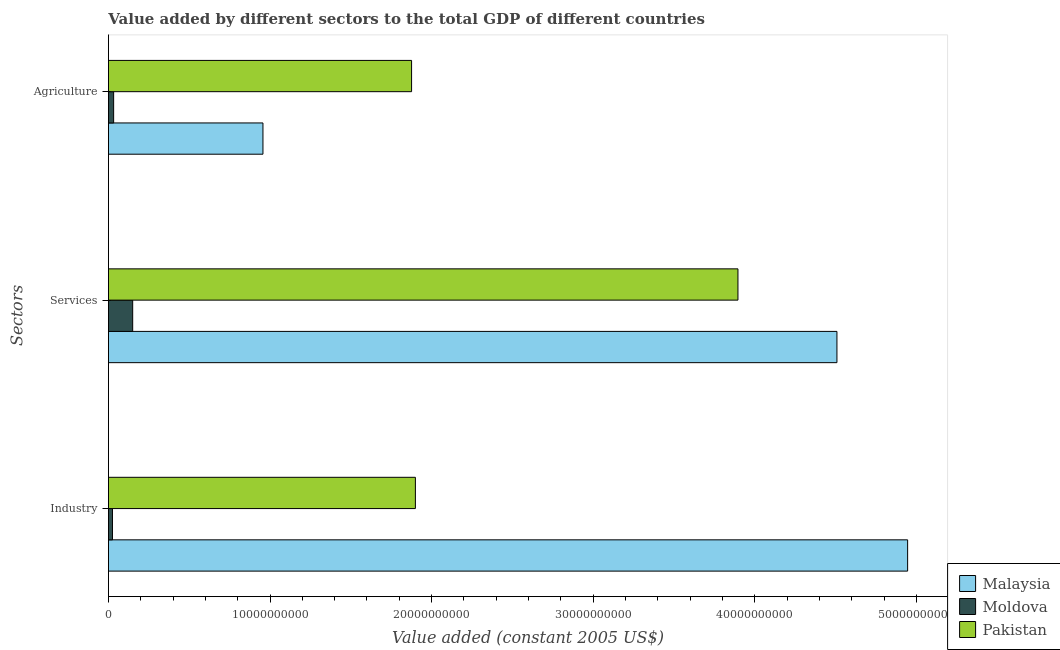How many groups of bars are there?
Give a very brief answer. 3. Are the number of bars per tick equal to the number of legend labels?
Ensure brevity in your answer.  Yes. How many bars are there on the 3rd tick from the top?
Make the answer very short. 3. How many bars are there on the 1st tick from the bottom?
Provide a succinct answer. 3. What is the label of the 1st group of bars from the top?
Your answer should be very brief. Agriculture. What is the value added by agricultural sector in Moldova?
Provide a short and direct response. 3.22e+08. Across all countries, what is the maximum value added by services?
Offer a very short reply. 4.51e+1. Across all countries, what is the minimum value added by agricultural sector?
Your answer should be very brief. 3.22e+08. In which country was the value added by industrial sector maximum?
Your answer should be compact. Malaysia. In which country was the value added by industrial sector minimum?
Provide a short and direct response. Moldova. What is the total value added by industrial sector in the graph?
Make the answer very short. 6.87e+1. What is the difference between the value added by agricultural sector in Pakistan and that in Moldova?
Offer a very short reply. 1.84e+1. What is the difference between the value added by agricultural sector in Pakistan and the value added by services in Malaysia?
Keep it short and to the point. -2.63e+1. What is the average value added by agricultural sector per country?
Ensure brevity in your answer.  9.55e+09. What is the difference between the value added by industrial sector and value added by services in Moldova?
Offer a very short reply. -1.25e+09. In how many countries, is the value added by services greater than 46000000000 US$?
Offer a terse response. 0. What is the ratio of the value added by services in Malaysia to that in Moldova?
Your response must be concise. 30.03. Is the value added by agricultural sector in Moldova less than that in Pakistan?
Provide a short and direct response. Yes. Is the difference between the value added by industrial sector in Malaysia and Pakistan greater than the difference between the value added by services in Malaysia and Pakistan?
Provide a short and direct response. Yes. What is the difference between the highest and the second highest value added by industrial sector?
Your response must be concise. 3.05e+1. What is the difference between the highest and the lowest value added by services?
Provide a short and direct response. 4.36e+1. In how many countries, is the value added by industrial sector greater than the average value added by industrial sector taken over all countries?
Keep it short and to the point. 1. What does the 3rd bar from the top in Services represents?
Your answer should be compact. Malaysia. What does the 1st bar from the bottom in Industry represents?
Keep it short and to the point. Malaysia. Is it the case that in every country, the sum of the value added by industrial sector and value added by services is greater than the value added by agricultural sector?
Provide a short and direct response. Yes. Are all the bars in the graph horizontal?
Offer a terse response. Yes. How many countries are there in the graph?
Provide a short and direct response. 3. Does the graph contain any zero values?
Provide a succinct answer. No. Where does the legend appear in the graph?
Your answer should be very brief. Bottom right. How many legend labels are there?
Your response must be concise. 3. How are the legend labels stacked?
Your response must be concise. Vertical. What is the title of the graph?
Offer a terse response. Value added by different sectors to the total GDP of different countries. Does "Japan" appear as one of the legend labels in the graph?
Give a very brief answer. No. What is the label or title of the X-axis?
Give a very brief answer. Value added (constant 2005 US$). What is the label or title of the Y-axis?
Make the answer very short. Sectors. What is the Value added (constant 2005 US$) of Malaysia in Industry?
Your response must be concise. 4.95e+1. What is the Value added (constant 2005 US$) in Moldova in Industry?
Provide a short and direct response. 2.50e+08. What is the Value added (constant 2005 US$) of Pakistan in Industry?
Offer a very short reply. 1.90e+1. What is the Value added (constant 2005 US$) in Malaysia in Services?
Provide a succinct answer. 4.51e+1. What is the Value added (constant 2005 US$) in Moldova in Services?
Offer a terse response. 1.50e+09. What is the Value added (constant 2005 US$) of Pakistan in Services?
Ensure brevity in your answer.  3.90e+1. What is the Value added (constant 2005 US$) in Malaysia in Agriculture?
Provide a succinct answer. 9.56e+09. What is the Value added (constant 2005 US$) in Moldova in Agriculture?
Give a very brief answer. 3.22e+08. What is the Value added (constant 2005 US$) in Pakistan in Agriculture?
Keep it short and to the point. 1.88e+1. Across all Sectors, what is the maximum Value added (constant 2005 US$) in Malaysia?
Offer a very short reply. 4.95e+1. Across all Sectors, what is the maximum Value added (constant 2005 US$) of Moldova?
Your answer should be compact. 1.50e+09. Across all Sectors, what is the maximum Value added (constant 2005 US$) in Pakistan?
Ensure brevity in your answer.  3.90e+1. Across all Sectors, what is the minimum Value added (constant 2005 US$) in Malaysia?
Ensure brevity in your answer.  9.56e+09. Across all Sectors, what is the minimum Value added (constant 2005 US$) of Moldova?
Keep it short and to the point. 2.50e+08. Across all Sectors, what is the minimum Value added (constant 2005 US$) of Pakistan?
Your answer should be very brief. 1.88e+1. What is the total Value added (constant 2005 US$) of Malaysia in the graph?
Provide a short and direct response. 1.04e+11. What is the total Value added (constant 2005 US$) in Moldova in the graph?
Keep it short and to the point. 2.07e+09. What is the total Value added (constant 2005 US$) in Pakistan in the graph?
Give a very brief answer. 7.67e+1. What is the difference between the Value added (constant 2005 US$) of Malaysia in Industry and that in Services?
Your response must be concise. 4.37e+09. What is the difference between the Value added (constant 2005 US$) in Moldova in Industry and that in Services?
Provide a succinct answer. -1.25e+09. What is the difference between the Value added (constant 2005 US$) in Pakistan in Industry and that in Services?
Provide a short and direct response. -2.00e+1. What is the difference between the Value added (constant 2005 US$) of Malaysia in Industry and that in Agriculture?
Ensure brevity in your answer.  3.99e+1. What is the difference between the Value added (constant 2005 US$) of Moldova in Industry and that in Agriculture?
Provide a short and direct response. -7.22e+07. What is the difference between the Value added (constant 2005 US$) in Pakistan in Industry and that in Agriculture?
Provide a succinct answer. 2.36e+08. What is the difference between the Value added (constant 2005 US$) in Malaysia in Services and that in Agriculture?
Ensure brevity in your answer.  3.55e+1. What is the difference between the Value added (constant 2005 US$) in Moldova in Services and that in Agriculture?
Your answer should be very brief. 1.18e+09. What is the difference between the Value added (constant 2005 US$) in Pakistan in Services and that in Agriculture?
Keep it short and to the point. 2.02e+1. What is the difference between the Value added (constant 2005 US$) in Malaysia in Industry and the Value added (constant 2005 US$) in Moldova in Services?
Offer a very short reply. 4.80e+1. What is the difference between the Value added (constant 2005 US$) in Malaysia in Industry and the Value added (constant 2005 US$) in Pakistan in Services?
Offer a very short reply. 1.05e+1. What is the difference between the Value added (constant 2005 US$) in Moldova in Industry and the Value added (constant 2005 US$) in Pakistan in Services?
Keep it short and to the point. -3.87e+1. What is the difference between the Value added (constant 2005 US$) of Malaysia in Industry and the Value added (constant 2005 US$) of Moldova in Agriculture?
Provide a succinct answer. 4.91e+1. What is the difference between the Value added (constant 2005 US$) of Malaysia in Industry and the Value added (constant 2005 US$) of Pakistan in Agriculture?
Provide a short and direct response. 3.07e+1. What is the difference between the Value added (constant 2005 US$) in Moldova in Industry and the Value added (constant 2005 US$) in Pakistan in Agriculture?
Your answer should be compact. -1.85e+1. What is the difference between the Value added (constant 2005 US$) in Malaysia in Services and the Value added (constant 2005 US$) in Moldova in Agriculture?
Offer a terse response. 4.48e+1. What is the difference between the Value added (constant 2005 US$) of Malaysia in Services and the Value added (constant 2005 US$) of Pakistan in Agriculture?
Offer a very short reply. 2.63e+1. What is the difference between the Value added (constant 2005 US$) of Moldova in Services and the Value added (constant 2005 US$) of Pakistan in Agriculture?
Provide a succinct answer. -1.73e+1. What is the average Value added (constant 2005 US$) of Malaysia per Sectors?
Provide a succinct answer. 3.47e+1. What is the average Value added (constant 2005 US$) of Moldova per Sectors?
Keep it short and to the point. 6.91e+08. What is the average Value added (constant 2005 US$) of Pakistan per Sectors?
Offer a terse response. 2.56e+1. What is the difference between the Value added (constant 2005 US$) of Malaysia and Value added (constant 2005 US$) of Moldova in Industry?
Provide a short and direct response. 4.92e+1. What is the difference between the Value added (constant 2005 US$) of Malaysia and Value added (constant 2005 US$) of Pakistan in Industry?
Ensure brevity in your answer.  3.05e+1. What is the difference between the Value added (constant 2005 US$) in Moldova and Value added (constant 2005 US$) in Pakistan in Industry?
Offer a very short reply. -1.87e+1. What is the difference between the Value added (constant 2005 US$) of Malaysia and Value added (constant 2005 US$) of Moldova in Services?
Provide a succinct answer. 4.36e+1. What is the difference between the Value added (constant 2005 US$) in Malaysia and Value added (constant 2005 US$) in Pakistan in Services?
Ensure brevity in your answer.  6.13e+09. What is the difference between the Value added (constant 2005 US$) of Moldova and Value added (constant 2005 US$) of Pakistan in Services?
Ensure brevity in your answer.  -3.75e+1. What is the difference between the Value added (constant 2005 US$) of Malaysia and Value added (constant 2005 US$) of Moldova in Agriculture?
Provide a short and direct response. 9.24e+09. What is the difference between the Value added (constant 2005 US$) of Malaysia and Value added (constant 2005 US$) of Pakistan in Agriculture?
Give a very brief answer. -9.20e+09. What is the difference between the Value added (constant 2005 US$) of Moldova and Value added (constant 2005 US$) of Pakistan in Agriculture?
Provide a short and direct response. -1.84e+1. What is the ratio of the Value added (constant 2005 US$) in Malaysia in Industry to that in Services?
Your answer should be very brief. 1.1. What is the ratio of the Value added (constant 2005 US$) in Moldova in Industry to that in Services?
Your answer should be compact. 0.17. What is the ratio of the Value added (constant 2005 US$) in Pakistan in Industry to that in Services?
Give a very brief answer. 0.49. What is the ratio of the Value added (constant 2005 US$) in Malaysia in Industry to that in Agriculture?
Give a very brief answer. 5.17. What is the ratio of the Value added (constant 2005 US$) of Moldova in Industry to that in Agriculture?
Make the answer very short. 0.78. What is the ratio of the Value added (constant 2005 US$) of Pakistan in Industry to that in Agriculture?
Offer a terse response. 1.01. What is the ratio of the Value added (constant 2005 US$) of Malaysia in Services to that in Agriculture?
Provide a short and direct response. 4.71. What is the ratio of the Value added (constant 2005 US$) in Moldova in Services to that in Agriculture?
Your answer should be very brief. 4.66. What is the ratio of the Value added (constant 2005 US$) in Pakistan in Services to that in Agriculture?
Give a very brief answer. 2.08. What is the difference between the highest and the second highest Value added (constant 2005 US$) of Malaysia?
Your answer should be compact. 4.37e+09. What is the difference between the highest and the second highest Value added (constant 2005 US$) in Moldova?
Your response must be concise. 1.18e+09. What is the difference between the highest and the second highest Value added (constant 2005 US$) of Pakistan?
Provide a short and direct response. 2.00e+1. What is the difference between the highest and the lowest Value added (constant 2005 US$) in Malaysia?
Your answer should be very brief. 3.99e+1. What is the difference between the highest and the lowest Value added (constant 2005 US$) in Moldova?
Provide a succinct answer. 1.25e+09. What is the difference between the highest and the lowest Value added (constant 2005 US$) of Pakistan?
Your answer should be compact. 2.02e+1. 